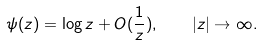<formula> <loc_0><loc_0><loc_500><loc_500>\psi ( z ) = \log z + O ( \frac { 1 } { z } ) , \quad | z | \rightarrow \infty .</formula> 